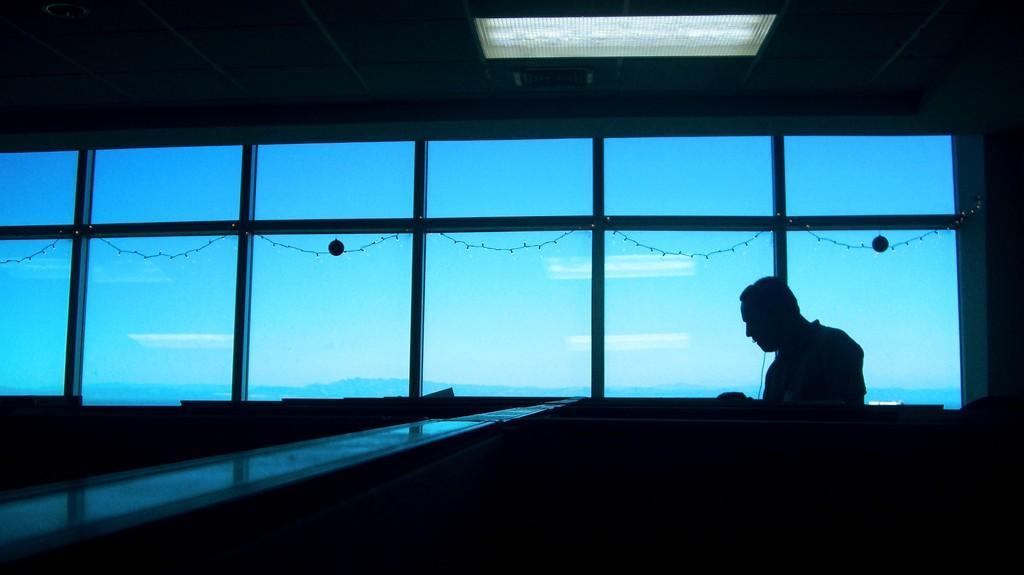In one or two sentences, can you explain what this image depicts? In this picture I can see there is a person sitting at the right side and there are few windows in the backdrop and there are few lights arranged here. The sky is visible from the window. 